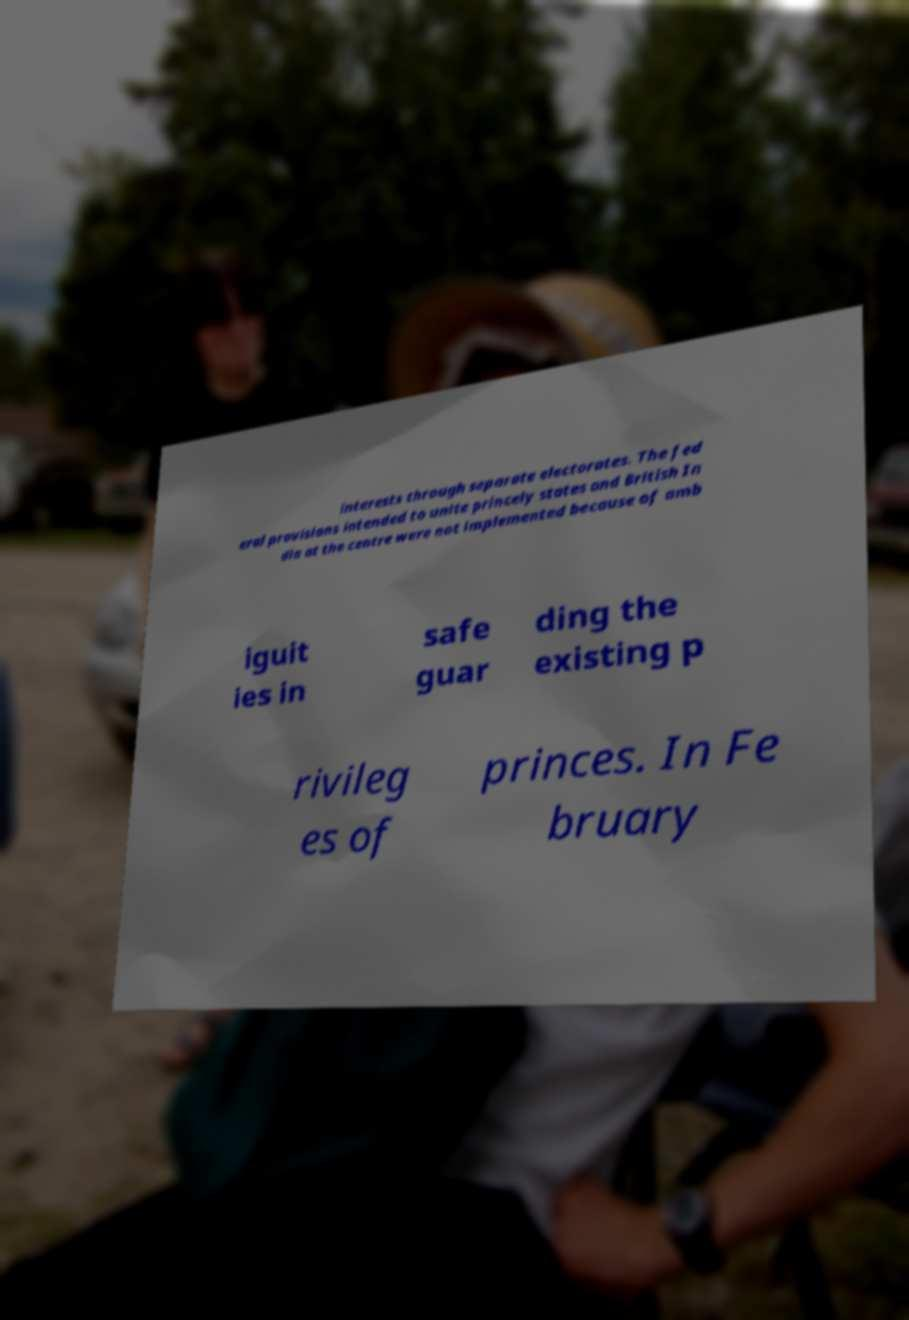Could you extract and type out the text from this image? interests through separate electorates. The fed eral provisions intended to unite princely states and British In dia at the centre were not implemented because of amb iguit ies in safe guar ding the existing p rivileg es of princes. In Fe bruary 